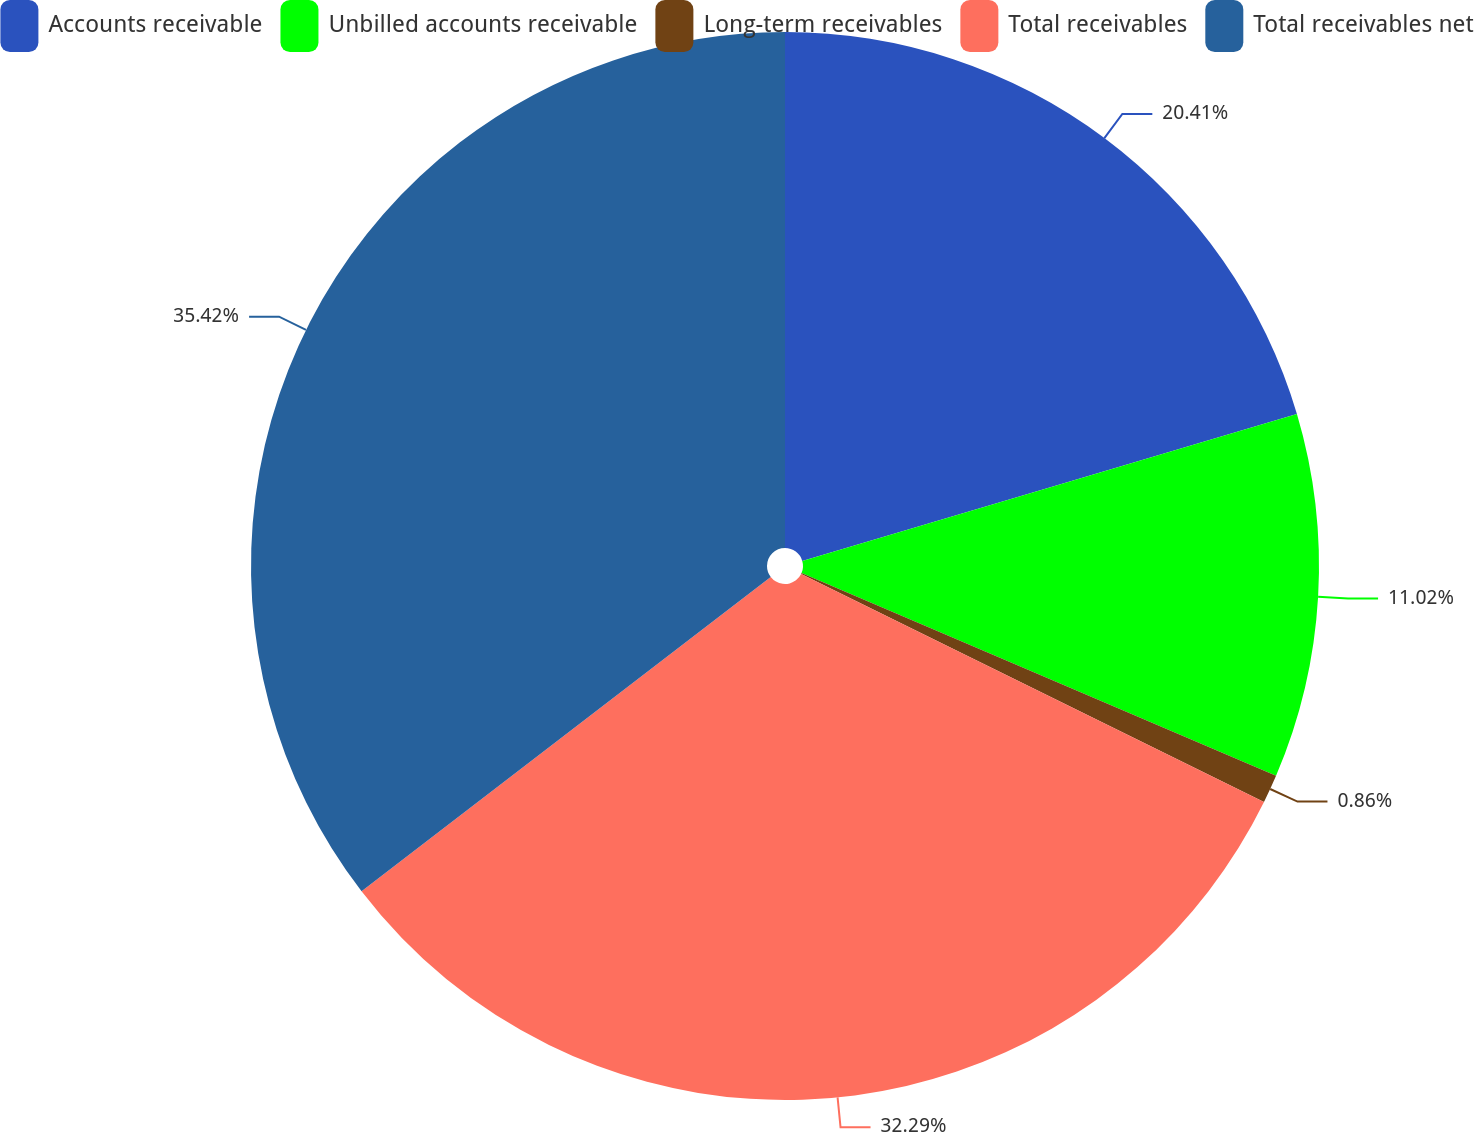Convert chart. <chart><loc_0><loc_0><loc_500><loc_500><pie_chart><fcel>Accounts receivable<fcel>Unbilled accounts receivable<fcel>Long-term receivables<fcel>Total receivables<fcel>Total receivables net<nl><fcel>20.41%<fcel>11.02%<fcel>0.86%<fcel>32.29%<fcel>35.43%<nl></chart> 